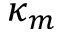<formula> <loc_0><loc_0><loc_500><loc_500>\kappa _ { m }</formula> 